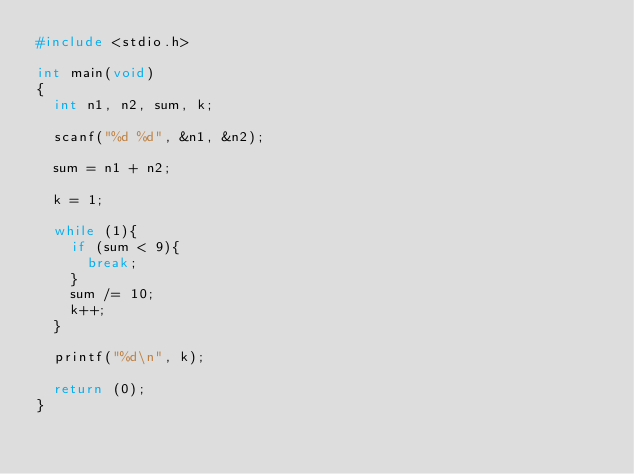<code> <loc_0><loc_0><loc_500><loc_500><_C_>#include <stdio.h>

int main(void)
{
	int n1, n2, sum, k;
	
	scanf("%d %d", &n1, &n2);
	
	sum = n1 + n2;
	
	k = 1;
	
	while (1){
		if (sum < 9){
			break;
		}
		sum /= 10;
		k++;
	}
	
	printf("%d\n", k);
	
	return (0);
}</code> 